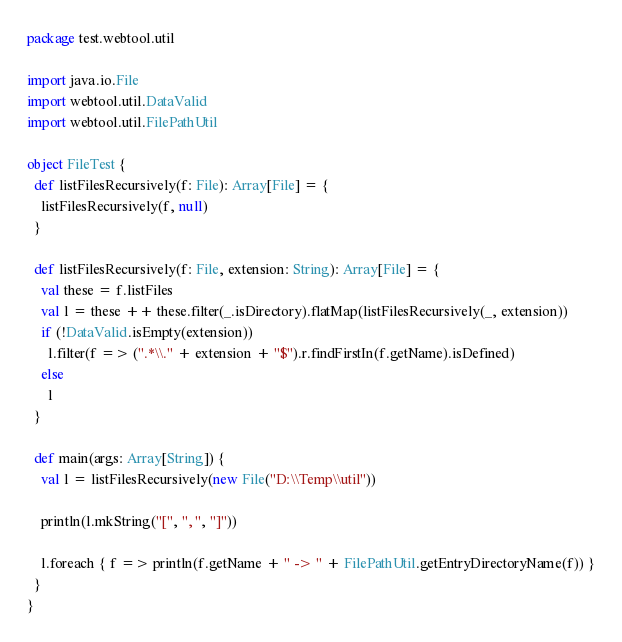<code> <loc_0><loc_0><loc_500><loc_500><_Scala_>package test.webtool.util

import java.io.File
import webtool.util.DataValid
import webtool.util.FilePathUtil

object FileTest {
  def listFilesRecursively(f: File): Array[File] = {
    listFilesRecursively(f, null)
  }

  def listFilesRecursively(f: File, extension: String): Array[File] = {
    val these = f.listFiles
    val l = these ++ these.filter(_.isDirectory).flatMap(listFilesRecursively(_, extension))
    if (!DataValid.isEmpty(extension))
      l.filter(f => (".*\\." + extension + "$").r.findFirstIn(f.getName).isDefined)
    else
      l
  }

  def main(args: Array[String]) {
    val l = listFilesRecursively(new File("D:\\Temp\\util"))

    println(l.mkString("[", ", ", "]"))
    
    l.foreach { f => println(f.getName + " -> " + FilePathUtil.getEntryDirectoryName(f)) }
  }
}</code> 